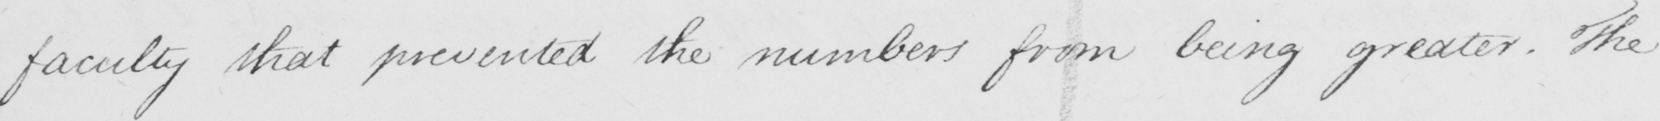What is written in this line of handwriting? faculty that prevented the numbers from being greater . The 